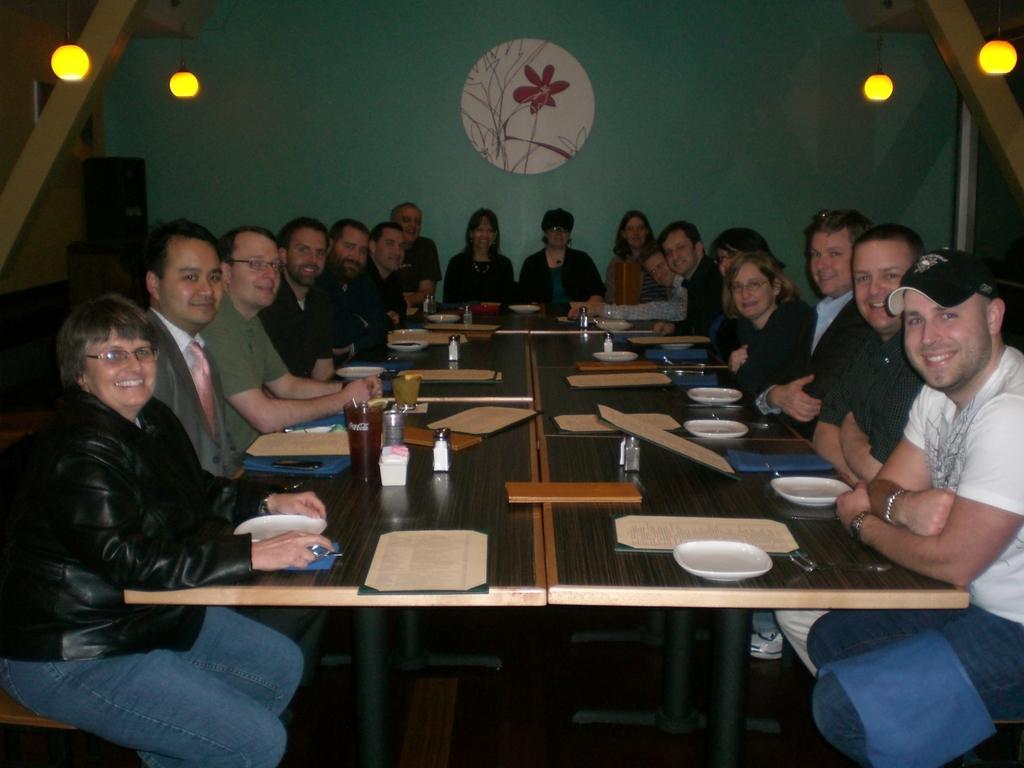Can you describe this image briefly? This image is clicked in a room where there are tables and benches. People are sitting on that benches near that table. On the table there is menu card, bottle, plates spoons. There are lights on the top 